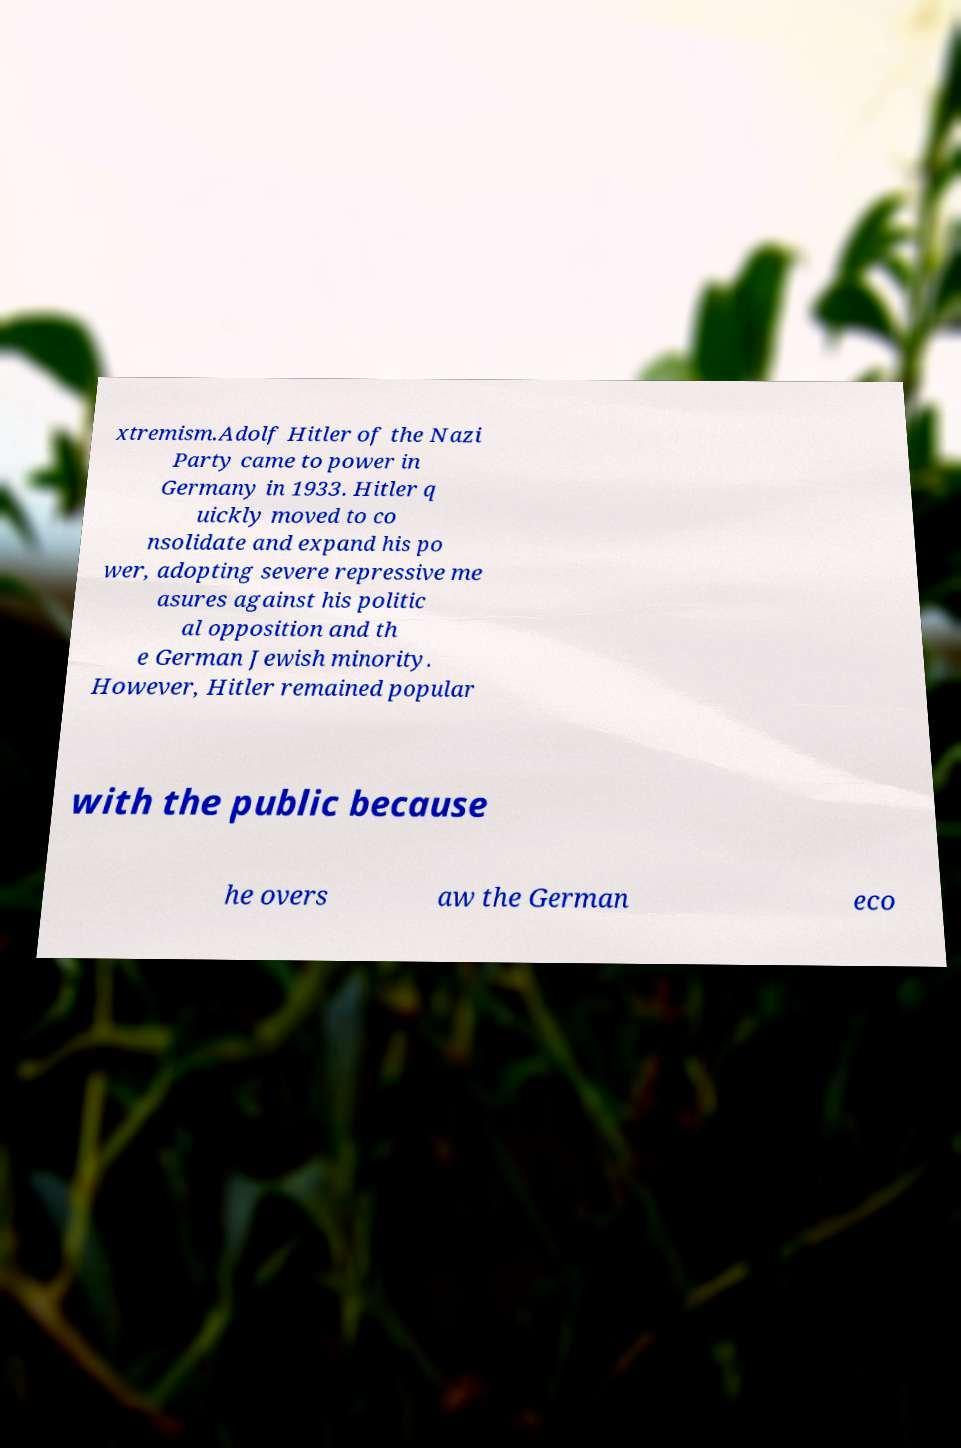Can you read and provide the text displayed in the image?This photo seems to have some interesting text. Can you extract and type it out for me? xtremism.Adolf Hitler of the Nazi Party came to power in Germany in 1933. Hitler q uickly moved to co nsolidate and expand his po wer, adopting severe repressive me asures against his politic al opposition and th e German Jewish minority. However, Hitler remained popular with the public because he overs aw the German eco 